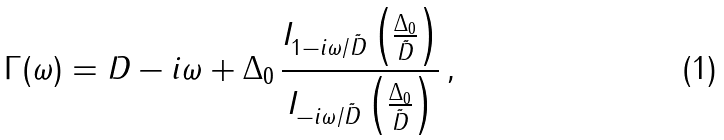Convert formula to latex. <formula><loc_0><loc_0><loc_500><loc_500>\Gamma ( \omega ) = D - i \omega + \Delta _ { 0 } \, \frac { I _ { 1 - i \omega / \tilde { D } } \left ( \frac { \Delta _ { 0 } } { \tilde { D } } \right ) } { I _ { - i \omega / \tilde { D } } \left ( \frac { \Delta _ { 0 } } { \tilde { D } } \right ) } \, ,</formula> 